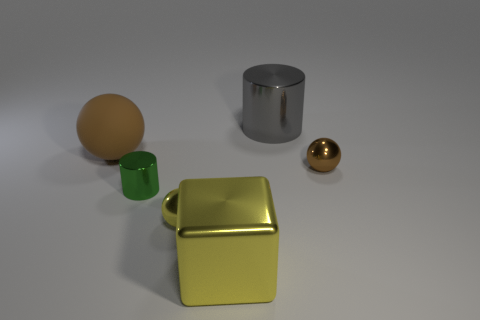There is a green metal thing that is the same size as the yellow metallic sphere; what is its shape?
Offer a very short reply. Cylinder. What number of brown things are big matte things or large metallic cylinders?
Offer a very short reply. 1. What number of yellow spheres have the same size as the gray metallic object?
Provide a short and direct response. 0. The tiny metallic thing that is the same color as the large metallic block is what shape?
Offer a very short reply. Sphere. How many objects are either cyan objects or things that are behind the small brown thing?
Ensure brevity in your answer.  2. Do the yellow metal thing behind the cube and the metal cylinder on the right side of the yellow cube have the same size?
Give a very brief answer. No. How many gray objects are the same shape as the large yellow metallic thing?
Make the answer very short. 0. What is the shape of the other large thing that is made of the same material as the large gray thing?
Give a very brief answer. Cube. There is a brown ball that is behind the small metallic sphere that is behind the metal sphere to the left of the small brown metal sphere; what is its material?
Make the answer very short. Rubber. Do the rubber ball and the metallic cylinder that is in front of the large brown object have the same size?
Give a very brief answer. No. 